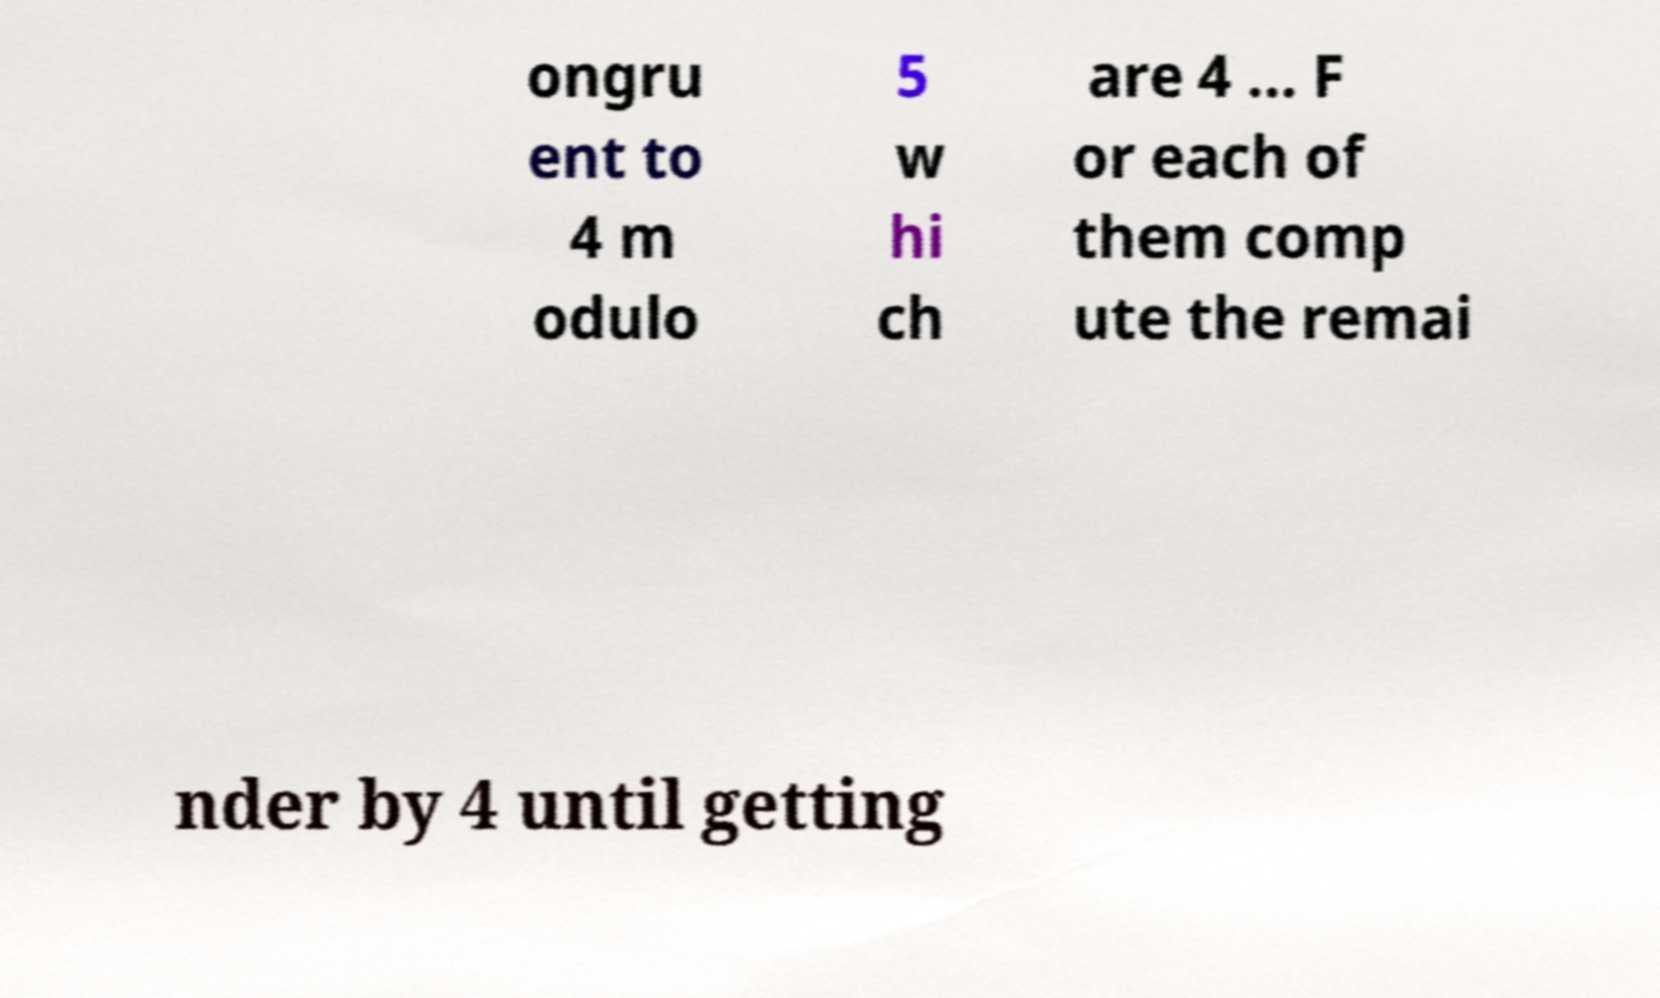For documentation purposes, I need the text within this image transcribed. Could you provide that? ongru ent to 4 m odulo 5 w hi ch are 4 ... F or each of them comp ute the remai nder by 4 until getting 